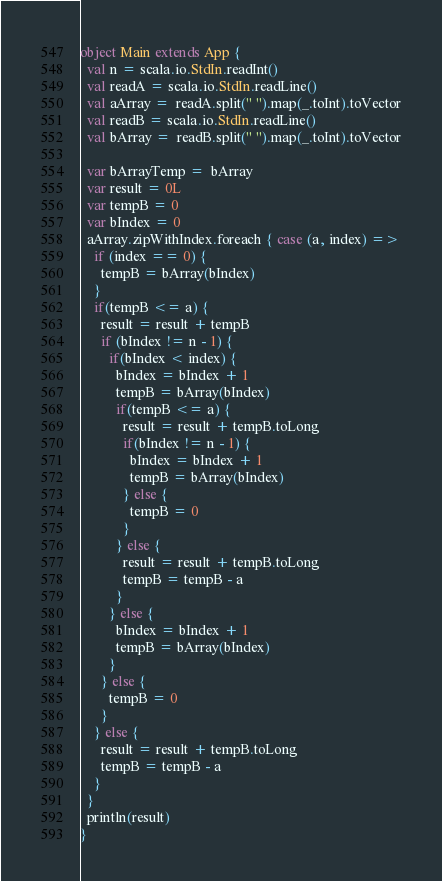Convert code to text. <code><loc_0><loc_0><loc_500><loc_500><_Scala_>object Main extends App {
  val n = scala.io.StdIn.readInt()
  val readA = scala.io.StdIn.readLine()
  val aArray =  readA.split(" ").map(_.toInt).toVector
  val readB = scala.io.StdIn.readLine()
  val bArray =  readB.split(" ").map(_.toInt).toVector

  var bArrayTemp =  bArray
  var result = 0L
  var tempB = 0
  var bIndex = 0
  aArray.zipWithIndex.foreach { case (a, index) =>
    if (index == 0) {
      tempB = bArray(bIndex)
    }
    if(tempB <= a) {
      result = result + tempB
      if (bIndex != n - 1) {
        if(bIndex < index) {
          bIndex = bIndex + 1
          tempB = bArray(bIndex)
          if(tempB <= a) {
            result = result + tempB.toLong
            if(bIndex != n - 1) {
              bIndex = bIndex + 1
              tempB = bArray(bIndex)
            } else {
              tempB = 0
            }
          } else {
            result = result + tempB.toLong
            tempB = tempB - a
          }
        } else {
          bIndex = bIndex + 1
          tempB = bArray(bIndex)
        }
      } else {
        tempB = 0
      }
    } else {
      result = result + tempB.toLong
      tempB = tempB - a
    }
  }
  println(result)
}</code> 